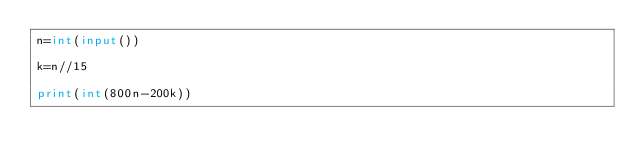Convert code to text. <code><loc_0><loc_0><loc_500><loc_500><_Python_>n=int(input())

k=n//15

print(int(800n-200k))</code> 